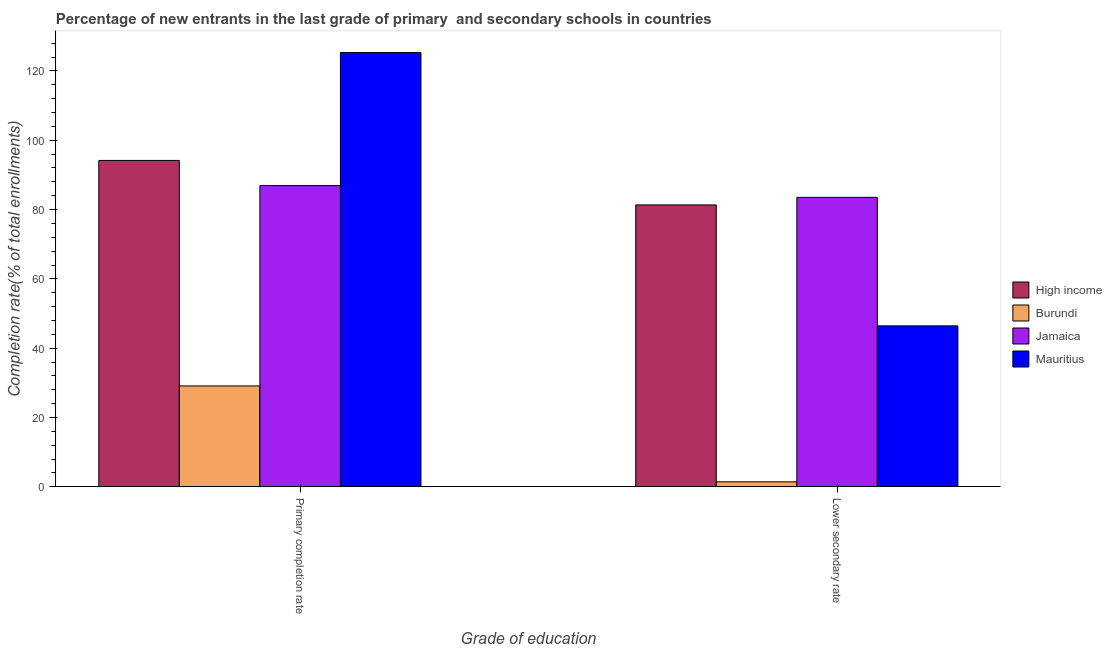How many different coloured bars are there?
Ensure brevity in your answer.  4. How many groups of bars are there?
Offer a very short reply. 2. Are the number of bars per tick equal to the number of legend labels?
Ensure brevity in your answer.  Yes. What is the label of the 2nd group of bars from the left?
Your answer should be very brief. Lower secondary rate. What is the completion rate in primary schools in High income?
Give a very brief answer. 94.19. Across all countries, what is the maximum completion rate in primary schools?
Provide a succinct answer. 125.33. Across all countries, what is the minimum completion rate in primary schools?
Ensure brevity in your answer.  29.09. In which country was the completion rate in secondary schools maximum?
Your response must be concise. Jamaica. In which country was the completion rate in primary schools minimum?
Your answer should be very brief. Burundi. What is the total completion rate in primary schools in the graph?
Ensure brevity in your answer.  335.52. What is the difference between the completion rate in primary schools in High income and that in Mauritius?
Ensure brevity in your answer.  -31.14. What is the difference between the completion rate in secondary schools in Mauritius and the completion rate in primary schools in Burundi?
Offer a terse response. 17.34. What is the average completion rate in secondary schools per country?
Give a very brief answer. 53.18. What is the difference between the completion rate in secondary schools and completion rate in primary schools in Burundi?
Provide a succinct answer. -27.68. In how many countries, is the completion rate in secondary schools greater than 120 %?
Ensure brevity in your answer.  0. What is the ratio of the completion rate in primary schools in Mauritius to that in High income?
Provide a succinct answer. 1.33. Is the completion rate in secondary schools in High income less than that in Burundi?
Offer a terse response. No. What does the 1st bar from the right in Primary completion rate represents?
Provide a succinct answer. Mauritius. Are all the bars in the graph horizontal?
Offer a very short reply. No. How many legend labels are there?
Keep it short and to the point. 4. What is the title of the graph?
Your response must be concise. Percentage of new entrants in the last grade of primary  and secondary schools in countries. What is the label or title of the X-axis?
Offer a very short reply. Grade of education. What is the label or title of the Y-axis?
Provide a short and direct response. Completion rate(% of total enrollments). What is the Completion rate(% of total enrollments) of High income in Primary completion rate?
Your response must be concise. 94.19. What is the Completion rate(% of total enrollments) in Burundi in Primary completion rate?
Your answer should be very brief. 29.09. What is the Completion rate(% of total enrollments) of Jamaica in Primary completion rate?
Provide a succinct answer. 86.92. What is the Completion rate(% of total enrollments) of Mauritius in Primary completion rate?
Make the answer very short. 125.33. What is the Completion rate(% of total enrollments) in High income in Lower secondary rate?
Offer a very short reply. 81.34. What is the Completion rate(% of total enrollments) in Burundi in Lower secondary rate?
Your answer should be compact. 1.41. What is the Completion rate(% of total enrollments) in Jamaica in Lower secondary rate?
Your response must be concise. 83.53. What is the Completion rate(% of total enrollments) of Mauritius in Lower secondary rate?
Your response must be concise. 46.43. Across all Grade of education, what is the maximum Completion rate(% of total enrollments) of High income?
Provide a short and direct response. 94.19. Across all Grade of education, what is the maximum Completion rate(% of total enrollments) of Burundi?
Provide a short and direct response. 29.09. Across all Grade of education, what is the maximum Completion rate(% of total enrollments) in Jamaica?
Ensure brevity in your answer.  86.92. Across all Grade of education, what is the maximum Completion rate(% of total enrollments) of Mauritius?
Provide a succinct answer. 125.33. Across all Grade of education, what is the minimum Completion rate(% of total enrollments) in High income?
Your answer should be compact. 81.34. Across all Grade of education, what is the minimum Completion rate(% of total enrollments) in Burundi?
Keep it short and to the point. 1.41. Across all Grade of education, what is the minimum Completion rate(% of total enrollments) in Jamaica?
Your response must be concise. 83.53. Across all Grade of education, what is the minimum Completion rate(% of total enrollments) of Mauritius?
Offer a very short reply. 46.43. What is the total Completion rate(% of total enrollments) of High income in the graph?
Keep it short and to the point. 175.53. What is the total Completion rate(% of total enrollments) of Burundi in the graph?
Offer a terse response. 30.5. What is the total Completion rate(% of total enrollments) in Jamaica in the graph?
Provide a succinct answer. 170.45. What is the total Completion rate(% of total enrollments) in Mauritius in the graph?
Your response must be concise. 171.76. What is the difference between the Completion rate(% of total enrollments) in High income in Primary completion rate and that in Lower secondary rate?
Keep it short and to the point. 12.85. What is the difference between the Completion rate(% of total enrollments) of Burundi in Primary completion rate and that in Lower secondary rate?
Offer a terse response. 27.68. What is the difference between the Completion rate(% of total enrollments) of Jamaica in Primary completion rate and that in Lower secondary rate?
Offer a terse response. 3.39. What is the difference between the Completion rate(% of total enrollments) of Mauritius in Primary completion rate and that in Lower secondary rate?
Your answer should be very brief. 78.9. What is the difference between the Completion rate(% of total enrollments) in High income in Primary completion rate and the Completion rate(% of total enrollments) in Burundi in Lower secondary rate?
Your answer should be compact. 92.77. What is the difference between the Completion rate(% of total enrollments) of High income in Primary completion rate and the Completion rate(% of total enrollments) of Jamaica in Lower secondary rate?
Keep it short and to the point. 10.66. What is the difference between the Completion rate(% of total enrollments) in High income in Primary completion rate and the Completion rate(% of total enrollments) in Mauritius in Lower secondary rate?
Your answer should be compact. 47.76. What is the difference between the Completion rate(% of total enrollments) of Burundi in Primary completion rate and the Completion rate(% of total enrollments) of Jamaica in Lower secondary rate?
Give a very brief answer. -54.44. What is the difference between the Completion rate(% of total enrollments) of Burundi in Primary completion rate and the Completion rate(% of total enrollments) of Mauritius in Lower secondary rate?
Ensure brevity in your answer.  -17.34. What is the difference between the Completion rate(% of total enrollments) in Jamaica in Primary completion rate and the Completion rate(% of total enrollments) in Mauritius in Lower secondary rate?
Keep it short and to the point. 40.49. What is the average Completion rate(% of total enrollments) in High income per Grade of education?
Offer a terse response. 87.76. What is the average Completion rate(% of total enrollments) in Burundi per Grade of education?
Ensure brevity in your answer.  15.25. What is the average Completion rate(% of total enrollments) of Jamaica per Grade of education?
Keep it short and to the point. 85.22. What is the average Completion rate(% of total enrollments) in Mauritius per Grade of education?
Keep it short and to the point. 85.88. What is the difference between the Completion rate(% of total enrollments) in High income and Completion rate(% of total enrollments) in Burundi in Primary completion rate?
Provide a succinct answer. 65.09. What is the difference between the Completion rate(% of total enrollments) of High income and Completion rate(% of total enrollments) of Jamaica in Primary completion rate?
Ensure brevity in your answer.  7.27. What is the difference between the Completion rate(% of total enrollments) of High income and Completion rate(% of total enrollments) of Mauritius in Primary completion rate?
Provide a succinct answer. -31.14. What is the difference between the Completion rate(% of total enrollments) of Burundi and Completion rate(% of total enrollments) of Jamaica in Primary completion rate?
Your answer should be compact. -57.83. What is the difference between the Completion rate(% of total enrollments) in Burundi and Completion rate(% of total enrollments) in Mauritius in Primary completion rate?
Ensure brevity in your answer.  -96.24. What is the difference between the Completion rate(% of total enrollments) of Jamaica and Completion rate(% of total enrollments) of Mauritius in Primary completion rate?
Offer a terse response. -38.41. What is the difference between the Completion rate(% of total enrollments) of High income and Completion rate(% of total enrollments) of Burundi in Lower secondary rate?
Keep it short and to the point. 79.93. What is the difference between the Completion rate(% of total enrollments) of High income and Completion rate(% of total enrollments) of Jamaica in Lower secondary rate?
Your response must be concise. -2.19. What is the difference between the Completion rate(% of total enrollments) of High income and Completion rate(% of total enrollments) of Mauritius in Lower secondary rate?
Give a very brief answer. 34.91. What is the difference between the Completion rate(% of total enrollments) in Burundi and Completion rate(% of total enrollments) in Jamaica in Lower secondary rate?
Make the answer very short. -82.11. What is the difference between the Completion rate(% of total enrollments) in Burundi and Completion rate(% of total enrollments) in Mauritius in Lower secondary rate?
Keep it short and to the point. -45.02. What is the difference between the Completion rate(% of total enrollments) in Jamaica and Completion rate(% of total enrollments) in Mauritius in Lower secondary rate?
Provide a short and direct response. 37.1. What is the ratio of the Completion rate(% of total enrollments) in High income in Primary completion rate to that in Lower secondary rate?
Make the answer very short. 1.16. What is the ratio of the Completion rate(% of total enrollments) in Burundi in Primary completion rate to that in Lower secondary rate?
Ensure brevity in your answer.  20.59. What is the ratio of the Completion rate(% of total enrollments) in Jamaica in Primary completion rate to that in Lower secondary rate?
Ensure brevity in your answer.  1.04. What is the ratio of the Completion rate(% of total enrollments) in Mauritius in Primary completion rate to that in Lower secondary rate?
Make the answer very short. 2.7. What is the difference between the highest and the second highest Completion rate(% of total enrollments) in High income?
Your answer should be very brief. 12.85. What is the difference between the highest and the second highest Completion rate(% of total enrollments) in Burundi?
Keep it short and to the point. 27.68. What is the difference between the highest and the second highest Completion rate(% of total enrollments) in Jamaica?
Your response must be concise. 3.39. What is the difference between the highest and the second highest Completion rate(% of total enrollments) of Mauritius?
Offer a very short reply. 78.9. What is the difference between the highest and the lowest Completion rate(% of total enrollments) in High income?
Your answer should be compact. 12.85. What is the difference between the highest and the lowest Completion rate(% of total enrollments) in Burundi?
Offer a terse response. 27.68. What is the difference between the highest and the lowest Completion rate(% of total enrollments) in Jamaica?
Your response must be concise. 3.39. What is the difference between the highest and the lowest Completion rate(% of total enrollments) of Mauritius?
Offer a very short reply. 78.9. 